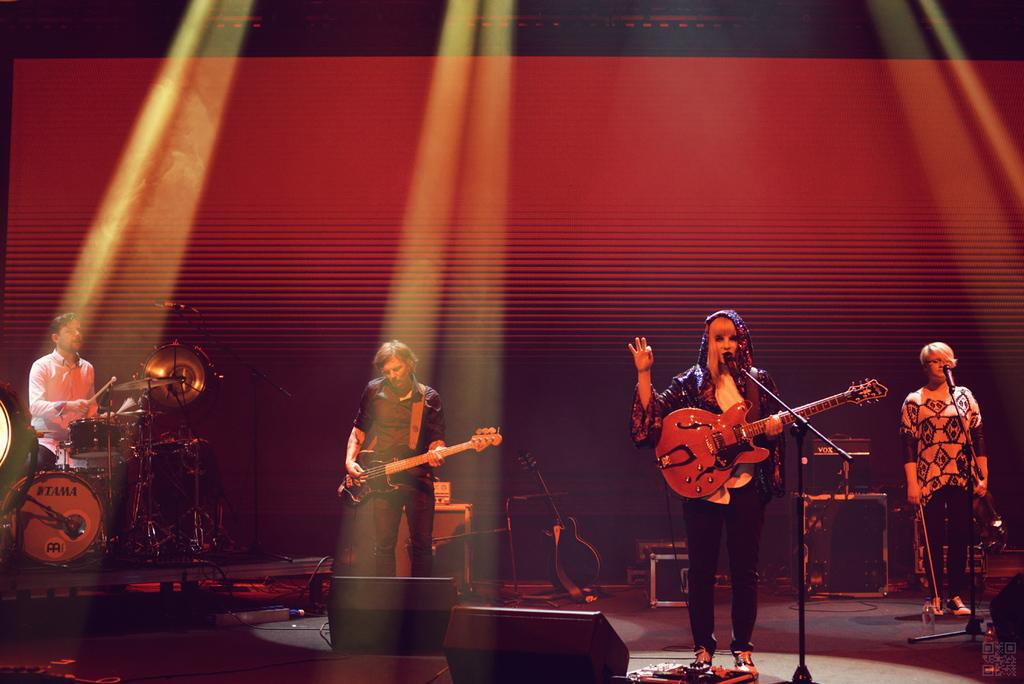How many people are in the image? There are four persons in the image. What are two of the persons holding? Two of the persons are holding guitars. What is one person doing in the image? One person is playing a musical instrument. What instrument is the fourth person holding? The fourth person is holding a violin. What equipment is present for amplifying sound in the image? There is a microphone with a stand in the image. What type of cherry is being used as a decoration on the microphone stand? There is no cherry present on the microphone stand in the image. What observation can be made about the musical instruments being played in the image? The provided facts do not mention any observations about the musical instruments being played; they only mention the instruments being held. 